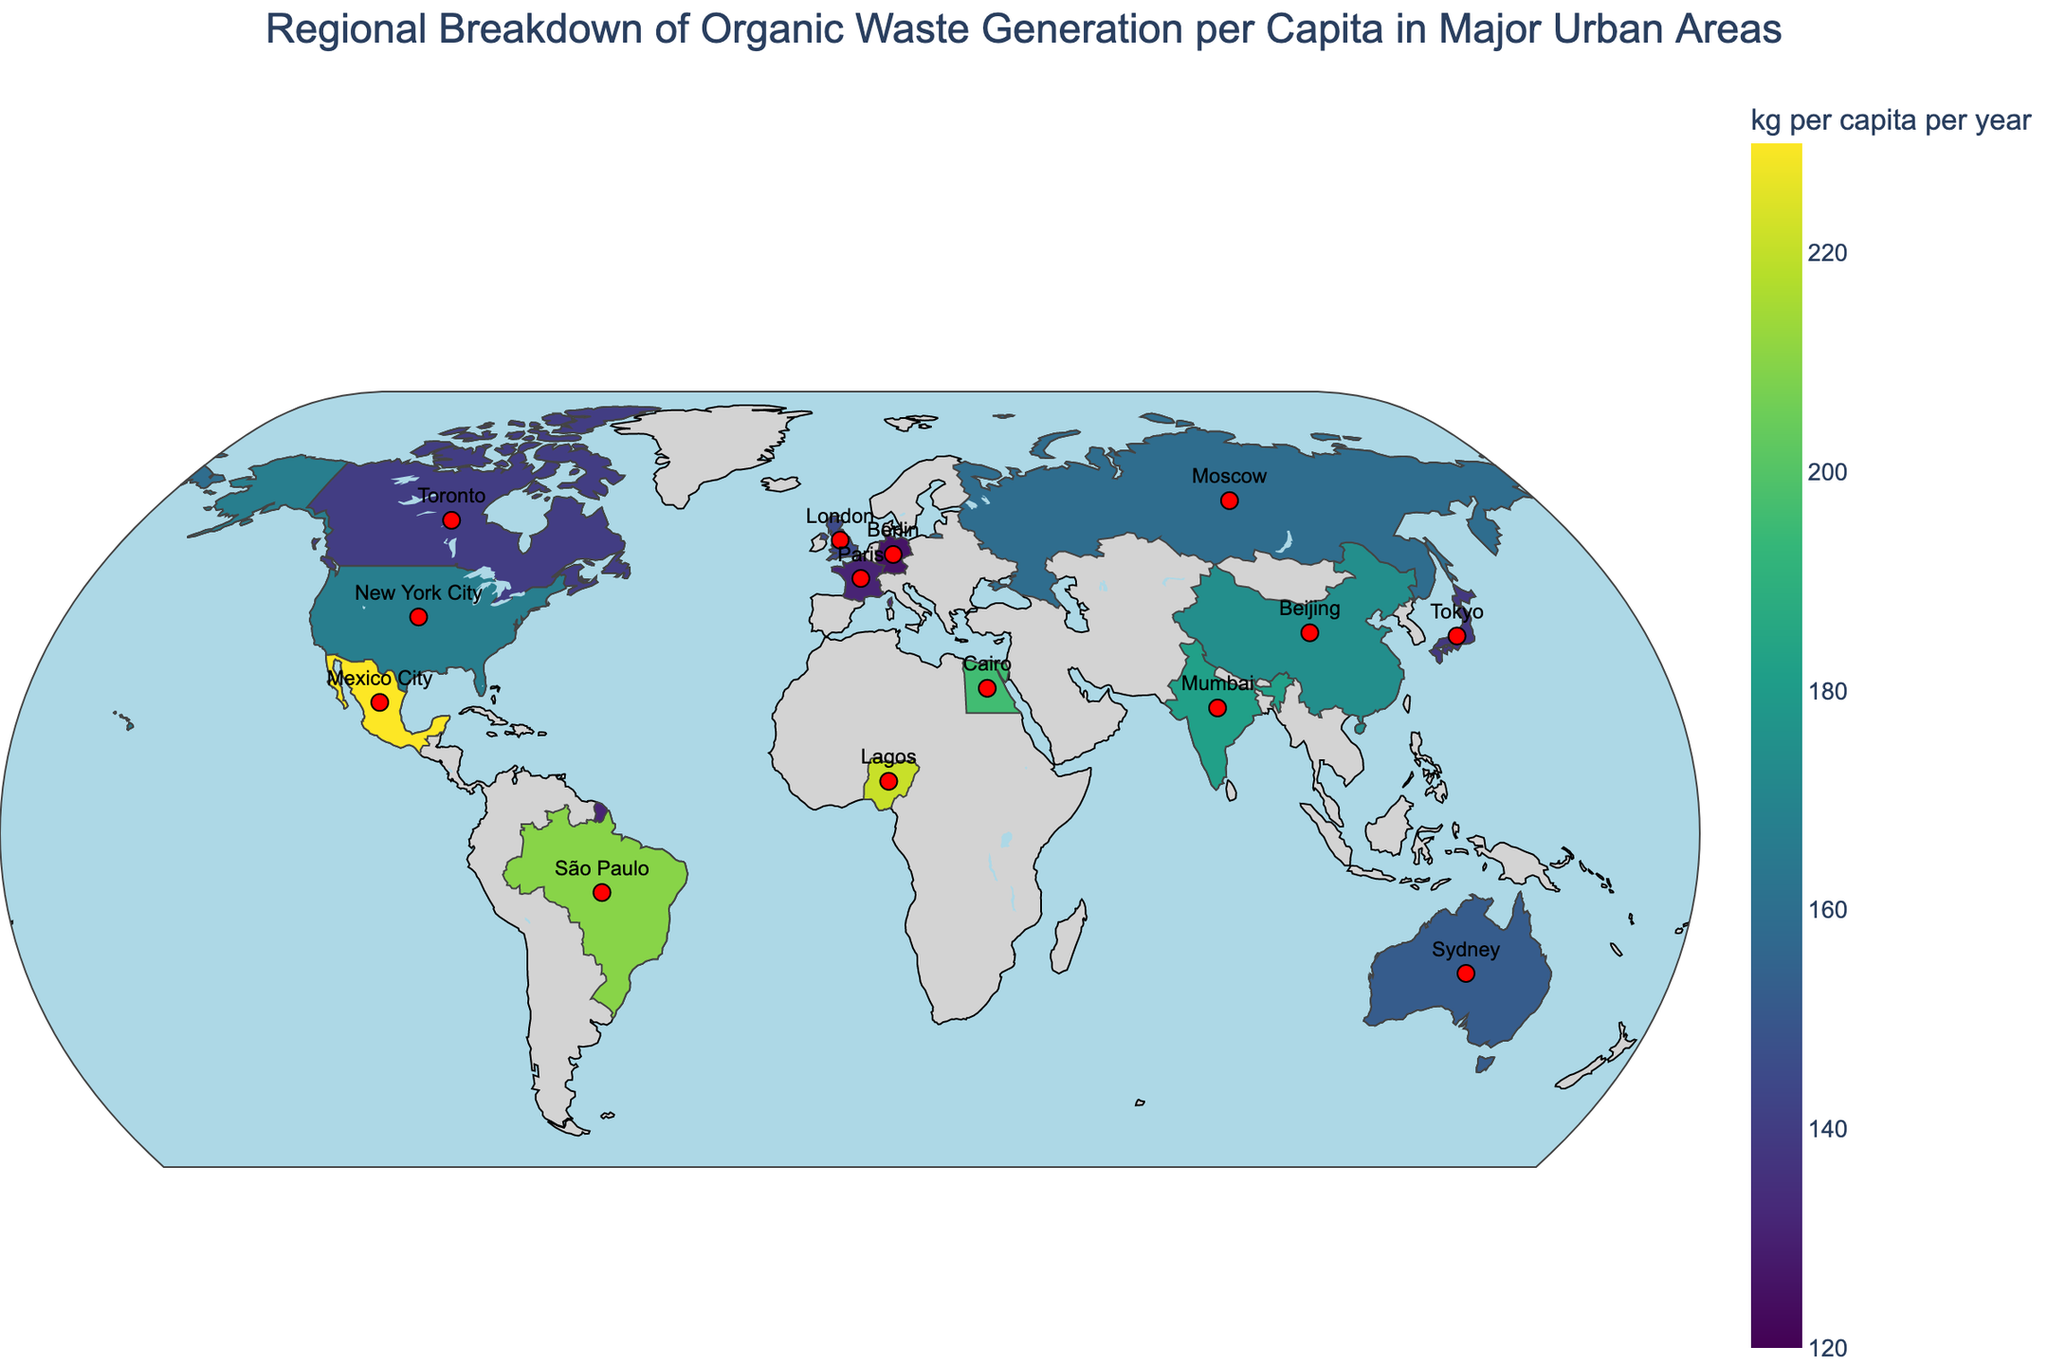What's the title of the figure? The title is located at the top and centered in the figure. It reads "Regional Breakdown of Organic Waste Generation per Capita in Major Urban Areas."
Answer: Regional Breakdown of Organic Waste Generation per Capita in Major Urban Areas Which city has the highest organic waste generation per capita? By looking at the color intensity on the map and identifying the city with the highest value on the color bar, Mexico City stands out with the highest organic waste generation rate of 230 kg per capita per year.
Answer: Mexico City How does Tokyo's organic waste generation per capita compare to Sydney's? By comparing the values: Tokyo generates 138 kg per capita per year while Sydney generates 152 kg per capita per year. Hence, Sydney generates more organic waste per capita than Tokyo.
Answer: Sydney generates more What's the average organic waste generation per capita for the cities listed? Summing the values for all cities provided and dividing by the number of cities gives the average: (167 + 145 + 138 + 210 + 182 + 126 + 152 + 174 + 230 + 196 + 221 + 131 + 140 + 120 + 159) / 15 ≈ 167.8 kg per capita per year.
Answer: 167.8 kg per capita per year Which continent has the most cities listed in the plot? Identifying the continents for each city: North America has 3 (New York City, Toronto, Mexico City), South America has 1 (São Paulo), Europe has 4 (London, Berlin, Paris, Moscow), Asia has 4 (Tokyo, Mumbai, Beijing, Singapore), Africa has 1 (Cairo, Lagos), and Oceania has 1 (Sydney). Europe and Asia both are tied with the most, having 4 cities each.
Answer: Europe and Asia What is the range of organic waste generation per capita in the data? Calculating the range involves subtracting the smallest value from the largest value: 230 (Mexico City) - 120 (Singapore) = 110 kg per capita per year.
Answer: 110 kg per capita per year Which city represents the lowest organic waste generation per capita in the data? By referring to the values in the plot, Singapore has the lowest value at 120 kg per capita per year.
Answer: Singapore How does New York City's organic waste generation compare to Berlin's? New York City has an organic waste generation of 167 kg per capita per year, while Berlin has 126 kg per capita per year. Hence, New York City generates more organic waste per capita than Berlin.
Answer: New York City generates more What is the median organic waste generation per capita of the cities? To find the median, first, arrange the values in ascending order: 120, 126, 131, 138, 140, 145, 152, 159, 167, 174, 182, 196, 210, 221, 230. The median value in this odd-numbered dataset (n=15) is the 8th value: 159 kg per capita per year.
Answer: 159 kg per capita per year 